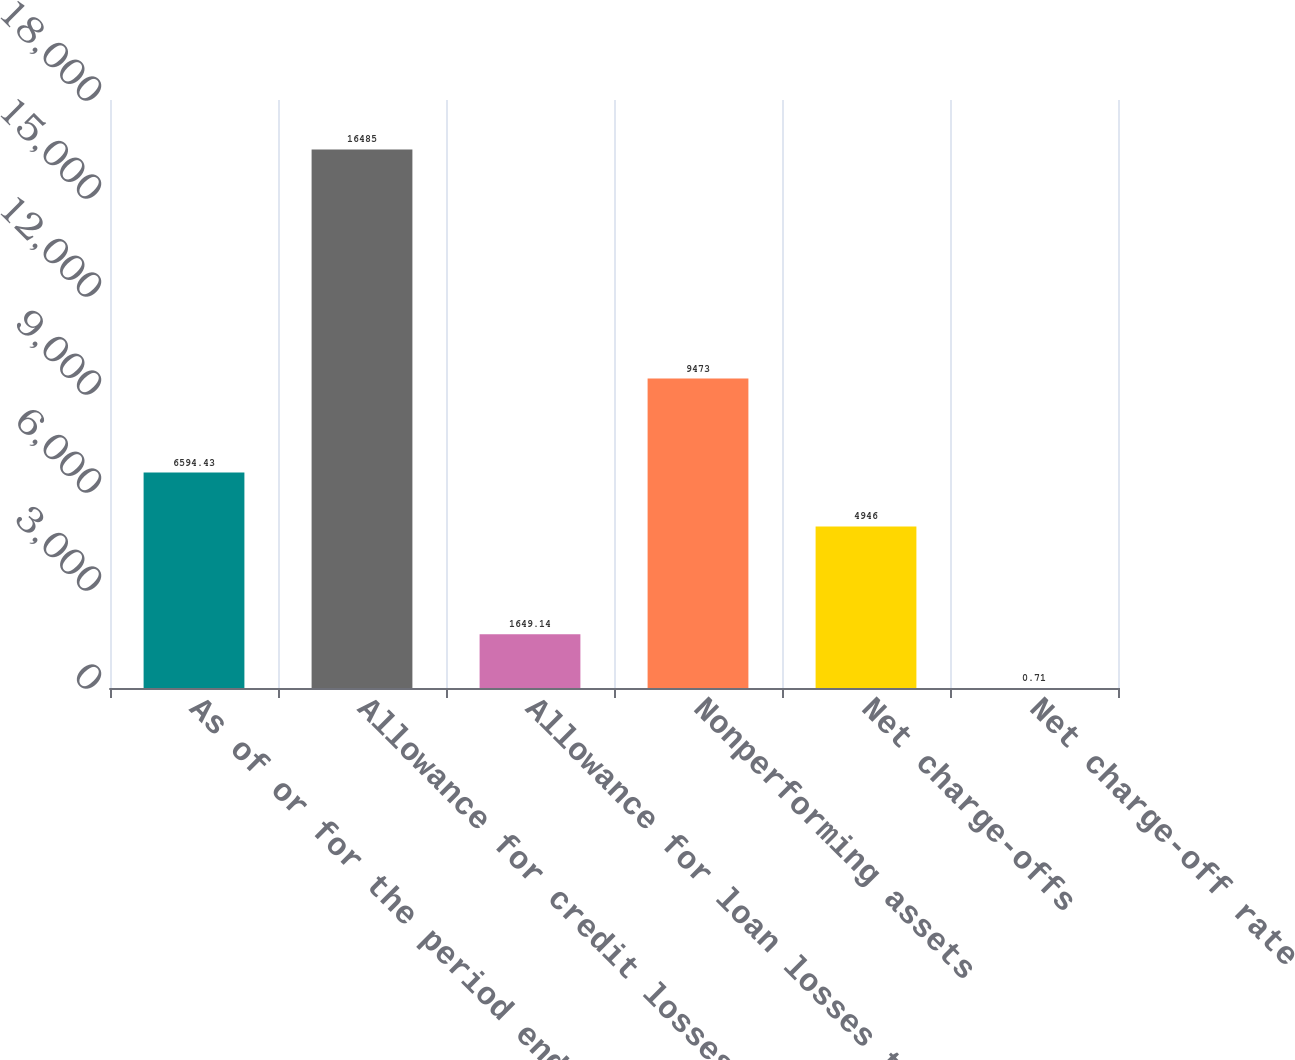<chart> <loc_0><loc_0><loc_500><loc_500><bar_chart><fcel>As of or for the period ended<fcel>Allowance for credit losses<fcel>Allowance for loan losses to<fcel>Nonperforming assets<fcel>Net charge-offs<fcel>Net charge-off rate<nl><fcel>6594.43<fcel>16485<fcel>1649.14<fcel>9473<fcel>4946<fcel>0.71<nl></chart> 